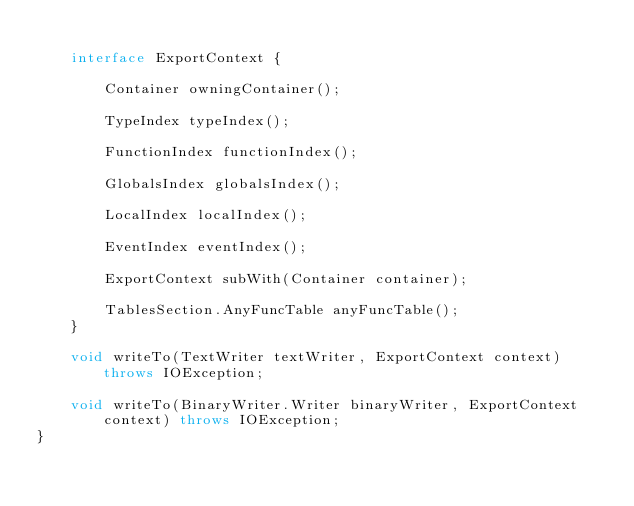<code> <loc_0><loc_0><loc_500><loc_500><_Java_>
    interface ExportContext {

        Container owningContainer();

        TypeIndex typeIndex();

        FunctionIndex functionIndex();

        GlobalsIndex globalsIndex();

        LocalIndex localIndex();

        EventIndex eventIndex();

        ExportContext subWith(Container container);

        TablesSection.AnyFuncTable anyFuncTable();
    }

    void writeTo(TextWriter textWriter, ExportContext context) throws IOException;

    void writeTo(BinaryWriter.Writer binaryWriter, ExportContext context) throws IOException;
}</code> 